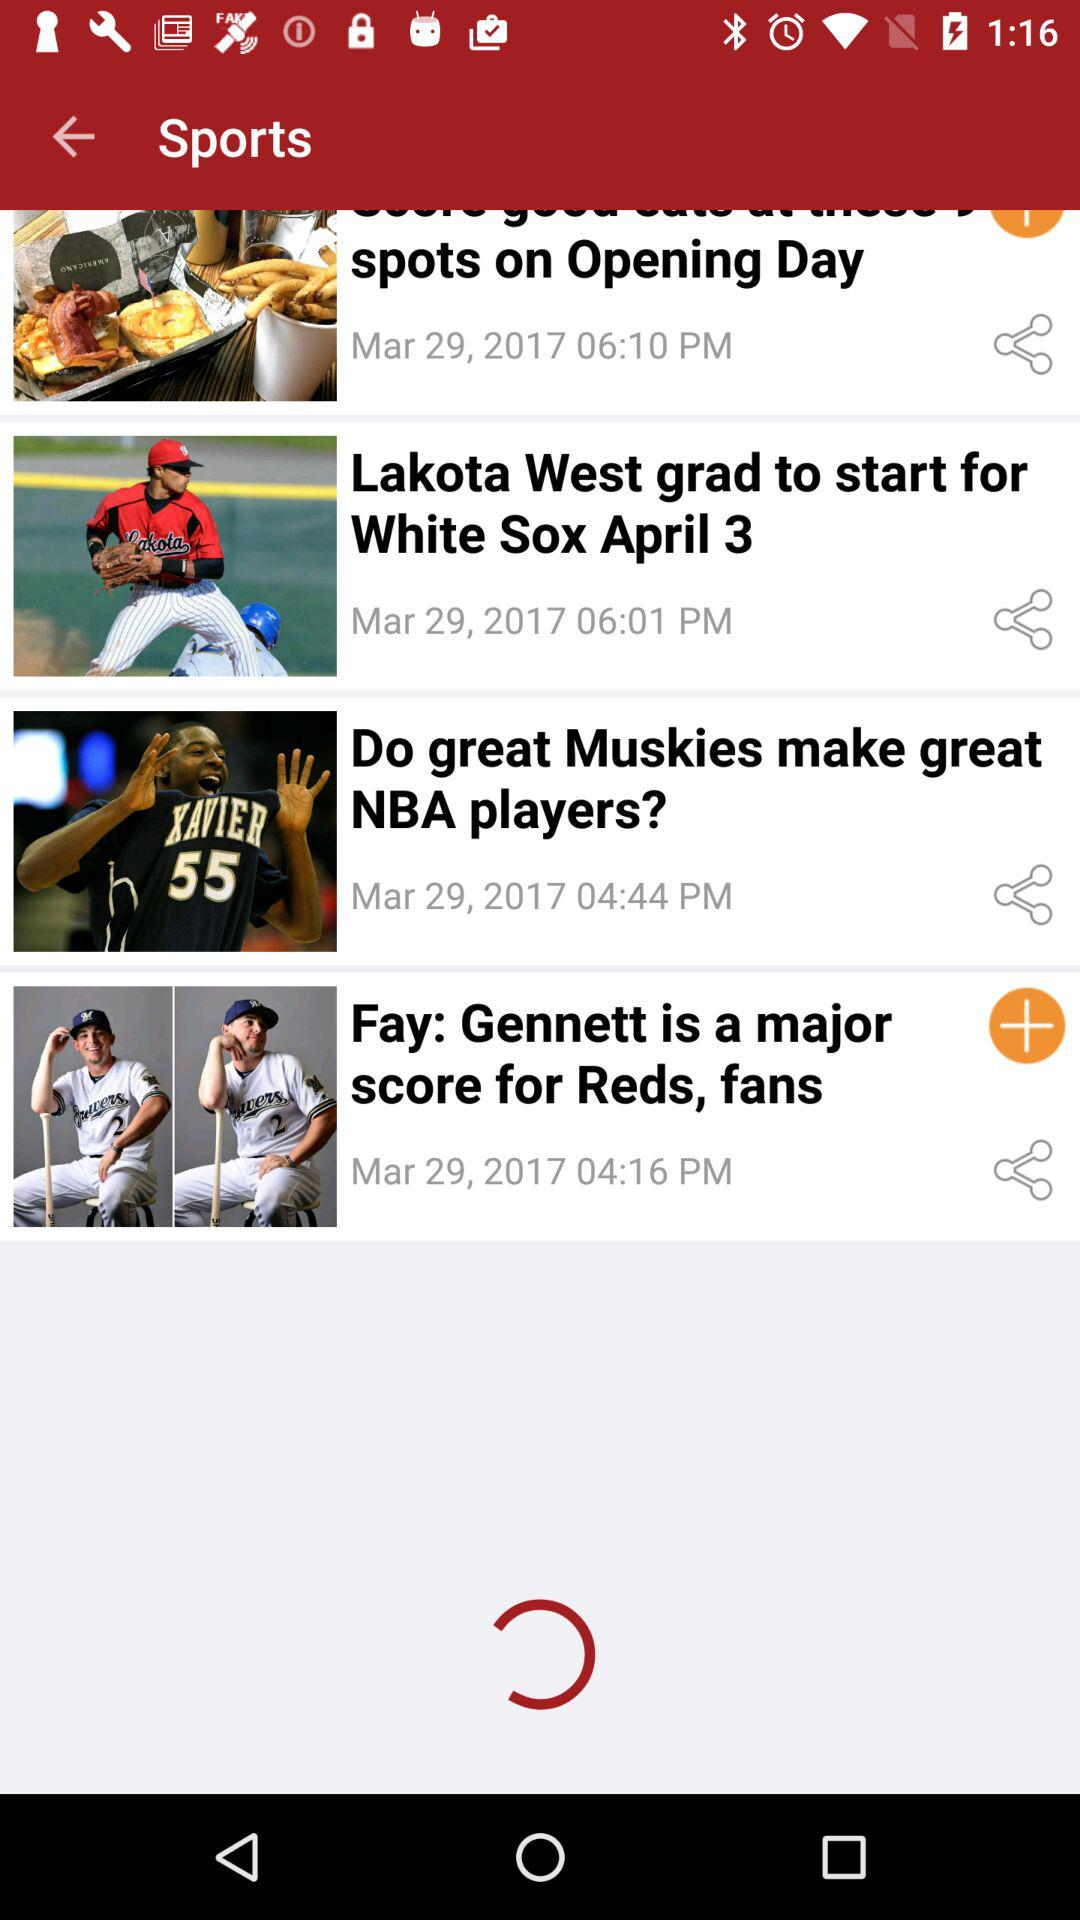How many sports articles are there?
Answer the question using a single word or phrase. 4 